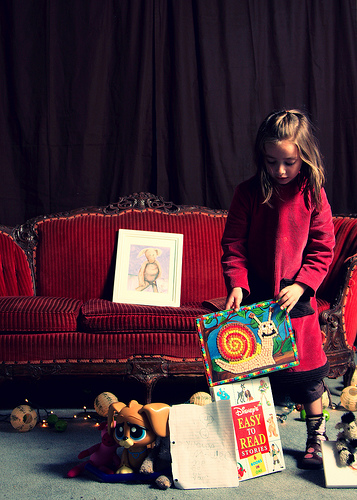<image>
Is there a snail on the book? Yes. Looking at the image, I can see the snail is positioned on top of the book, with the book providing support. Is the girl on the sofa? No. The girl is not positioned on the sofa. They may be near each other, but the girl is not supported by or resting on top of the sofa. Is the girl on the chair? No. The girl is not positioned on the chair. They may be near each other, but the girl is not supported by or resting on top of the chair. 